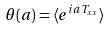<formula> <loc_0><loc_0><loc_500><loc_500>\theta ( a ) = \langle e ^ { i a T _ { x x } } \rangle</formula> 